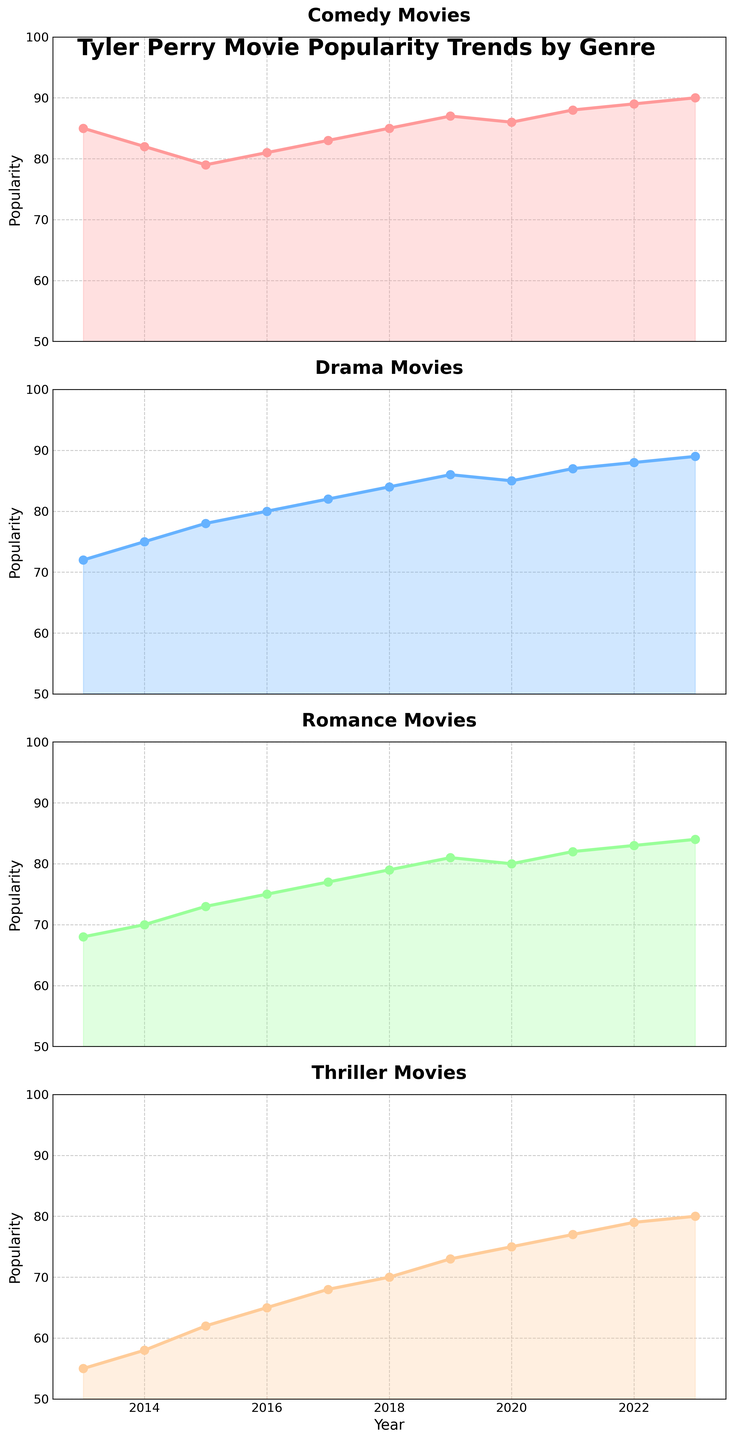What's the overall trend in popularity for Comedy movies over the past decade? The popularity of Comedy movies has gradually increased from 85 in 2013 to 90 in 2023.
Answer: Increasing Which genre had the smallest increase in popularity from 2013 to 2023? Calculate the change for each genre from 2013 to 2023: Comedy (90 - 85 = 5), Drama (89 - 72 = 17), Romance (84 - 68 = 16), Thriller (80 - 55 = 25). Thriller had the smallest increase.
Answer: Comedy In which years did Drama movies surpass the popularity score of 80? Drama movies surpassed the popularity score of 80 in the years 2016, 2017, 2018, 2019, 2020, 2021, 2022, and 2023.
Answer: 2016 to 2023 How much did the popularity of Thriller movies increase from 2013 to 2023? Subtract the popularity in 2013 from 2023: 80 - 55 = 25.
Answer: 25 Between Comedy and Romance, which genre had a greater popularity score in 2020? In 2020, Comedy had a popularity score of 86, while Romance had 80. Comedy is greater.
Answer: Comedy What's the average popularity score for Romance movies from 2013 to 2018? Add the scores from 2013 to 2018 and divide by 6: (68+70+73+75+77+79)/6 = 73.67.
Answer: 73.67 Which genre had the highest initial popularity score in 2013? Looking at the scores for 2013: Comedy (85), Drama (72), Romance (68), Thriller (55). Comedy had the highest score.
Answer: Comedy Did any genre experience a decline in popularity in any year? Check each genre's scores year by year. None of the genres show a decline from one year to the next; all show yearly increases.
Answer: No In which year did Thriller movies cross the popularity score of 75? Thriller movies crossed the popularity score of 75 in 2020.
Answer: 2020 What has been the trend in popularity for Drama movies from 2015 to 2020? Drama movies' popularity increased each year from 78 in 2015 to 85 in 2020.
Answer: Increasing 